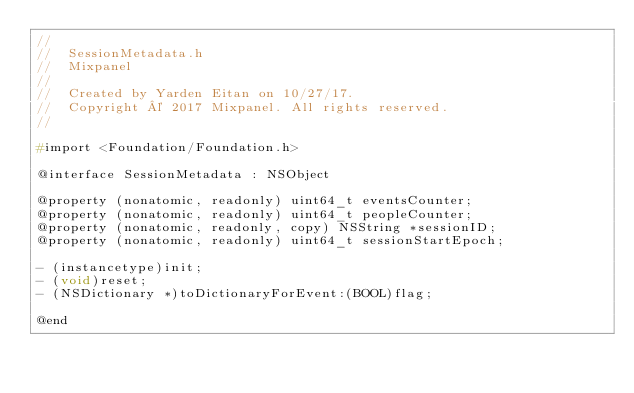<code> <loc_0><loc_0><loc_500><loc_500><_C_>//
//  SessionMetadata.h
//  Mixpanel
//
//  Created by Yarden Eitan on 10/27/17.
//  Copyright © 2017 Mixpanel. All rights reserved.
//

#import <Foundation/Foundation.h>

@interface SessionMetadata : NSObject

@property (nonatomic, readonly) uint64_t eventsCounter;
@property (nonatomic, readonly) uint64_t peopleCounter;
@property (nonatomic, readonly, copy) NSString *sessionID;
@property (nonatomic, readonly) uint64_t sessionStartEpoch;

- (instancetype)init;
- (void)reset;
- (NSDictionary *)toDictionaryForEvent:(BOOL)flag;

@end
</code> 